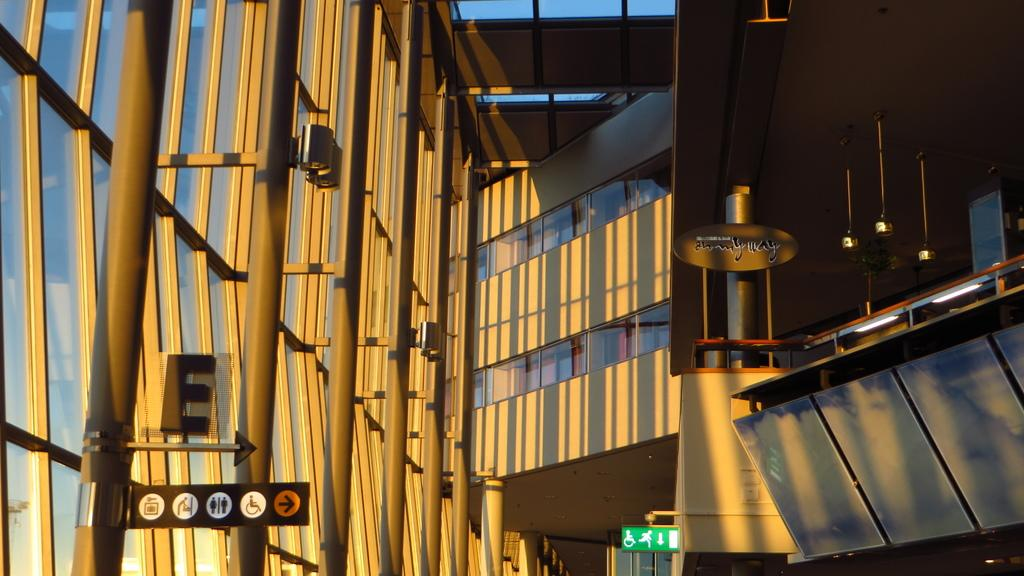Where was the image taken? The image was taken inside a building. What can be seen on the left side of the image? There is a direction board on the left side of the image. What is the color of the direction board? The direction board is green in color. Are there any light sources visible in the image? Yes, the image contains lights. What type of twig is being used to paint on the canvas in the image? There is no twig or canvas present in the image. How does the direction board blow in the wind in the image? The direction board does not blow in the wind in the image; it is stationary on the wall. 